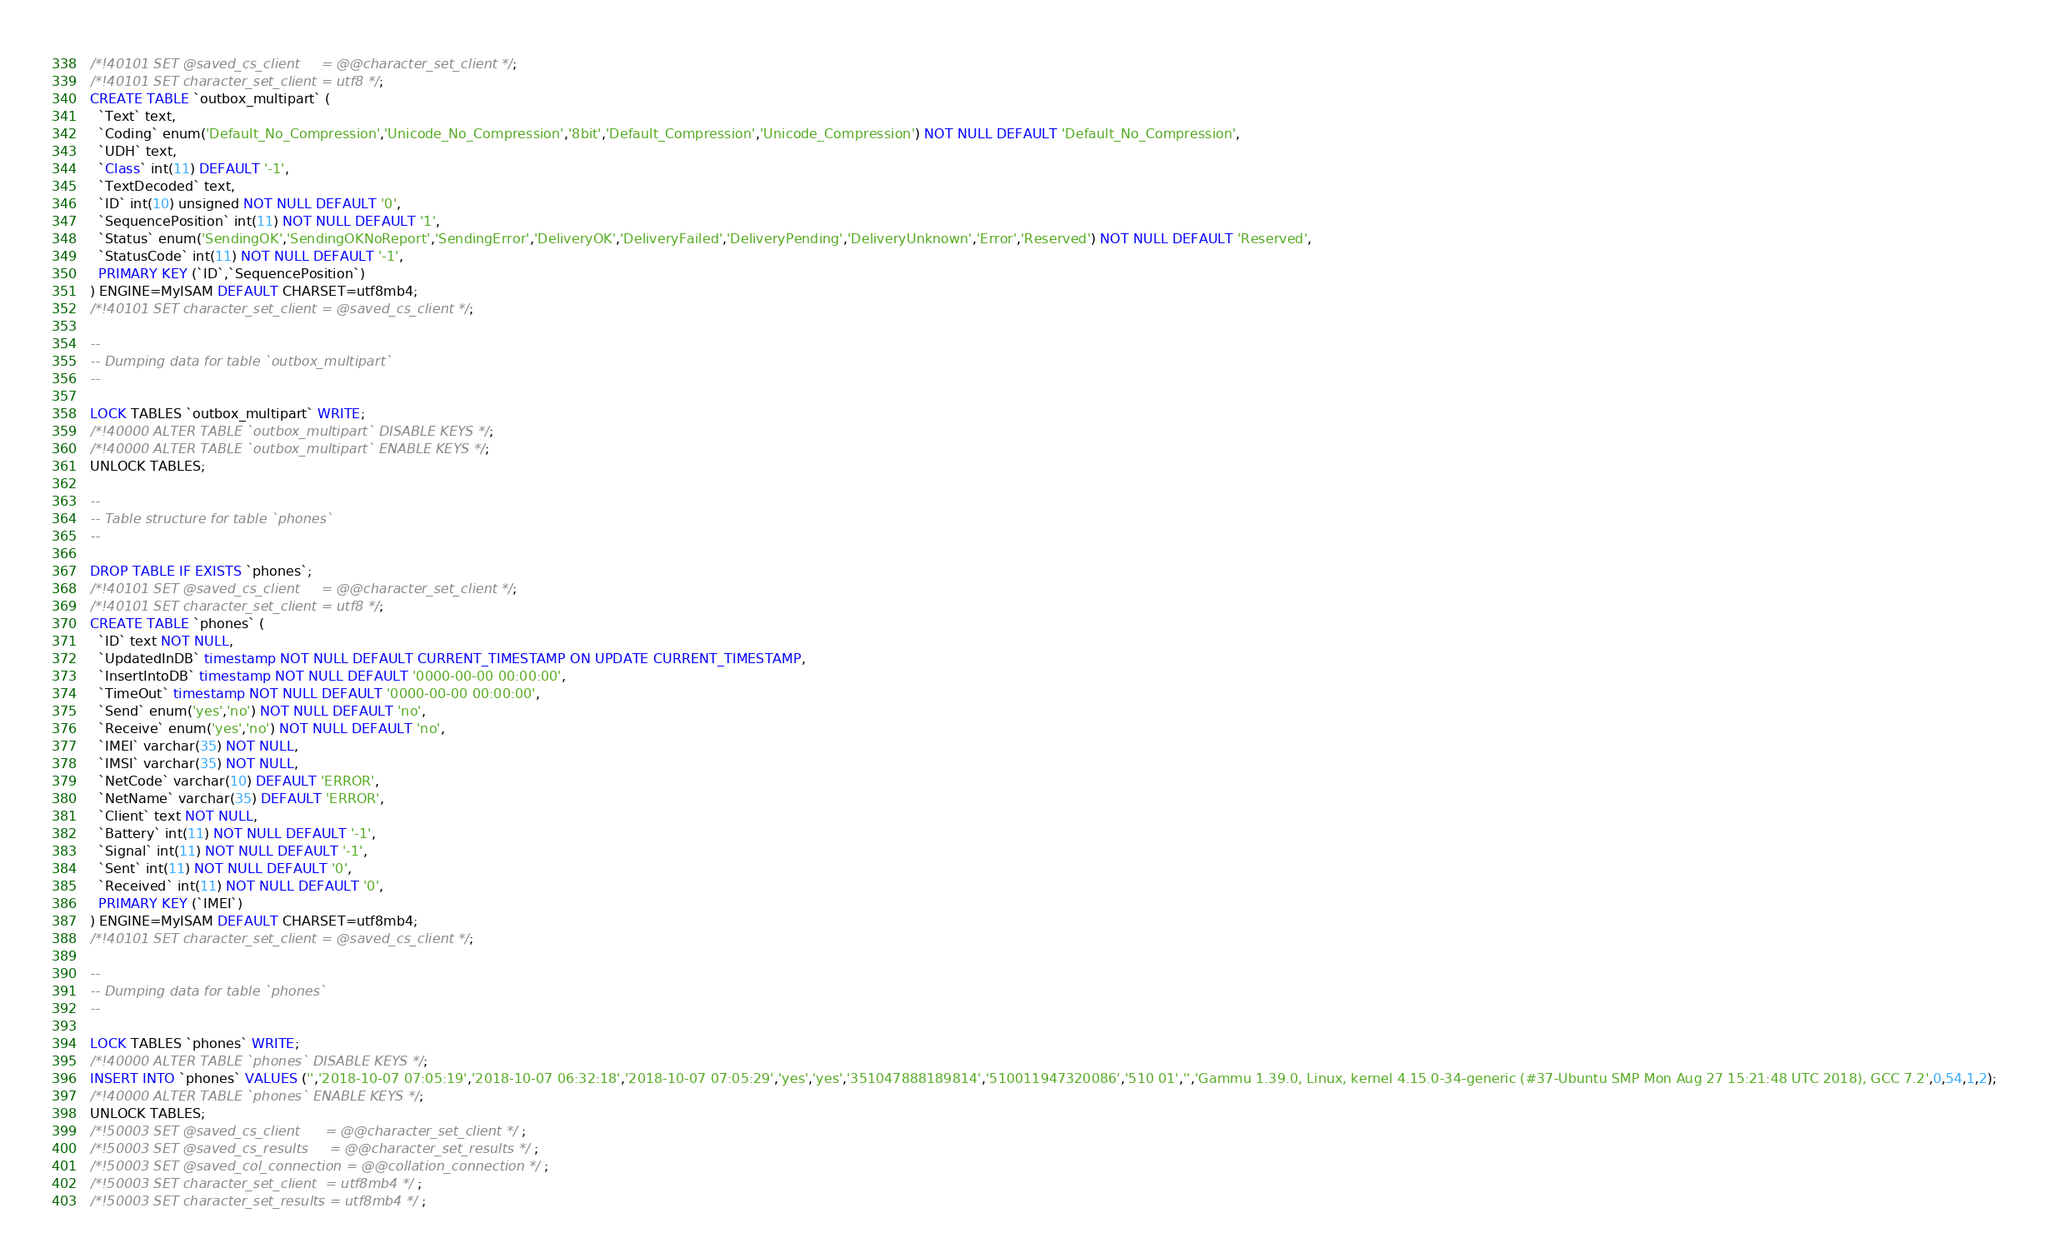Convert code to text. <code><loc_0><loc_0><loc_500><loc_500><_SQL_>/*!40101 SET @saved_cs_client     = @@character_set_client */;
/*!40101 SET character_set_client = utf8 */;
CREATE TABLE `outbox_multipart` (
  `Text` text,
  `Coding` enum('Default_No_Compression','Unicode_No_Compression','8bit','Default_Compression','Unicode_Compression') NOT NULL DEFAULT 'Default_No_Compression',
  `UDH` text,
  `Class` int(11) DEFAULT '-1',
  `TextDecoded` text,
  `ID` int(10) unsigned NOT NULL DEFAULT '0',
  `SequencePosition` int(11) NOT NULL DEFAULT '1',
  `Status` enum('SendingOK','SendingOKNoReport','SendingError','DeliveryOK','DeliveryFailed','DeliveryPending','DeliveryUnknown','Error','Reserved') NOT NULL DEFAULT 'Reserved',
  `StatusCode` int(11) NOT NULL DEFAULT '-1',
  PRIMARY KEY (`ID`,`SequencePosition`)
) ENGINE=MyISAM DEFAULT CHARSET=utf8mb4;
/*!40101 SET character_set_client = @saved_cs_client */;

--
-- Dumping data for table `outbox_multipart`
--

LOCK TABLES `outbox_multipart` WRITE;
/*!40000 ALTER TABLE `outbox_multipart` DISABLE KEYS */;
/*!40000 ALTER TABLE `outbox_multipart` ENABLE KEYS */;
UNLOCK TABLES;

--
-- Table structure for table `phones`
--

DROP TABLE IF EXISTS `phones`;
/*!40101 SET @saved_cs_client     = @@character_set_client */;
/*!40101 SET character_set_client = utf8 */;
CREATE TABLE `phones` (
  `ID` text NOT NULL,
  `UpdatedInDB` timestamp NOT NULL DEFAULT CURRENT_TIMESTAMP ON UPDATE CURRENT_TIMESTAMP,
  `InsertIntoDB` timestamp NOT NULL DEFAULT '0000-00-00 00:00:00',
  `TimeOut` timestamp NOT NULL DEFAULT '0000-00-00 00:00:00',
  `Send` enum('yes','no') NOT NULL DEFAULT 'no',
  `Receive` enum('yes','no') NOT NULL DEFAULT 'no',
  `IMEI` varchar(35) NOT NULL,
  `IMSI` varchar(35) NOT NULL,
  `NetCode` varchar(10) DEFAULT 'ERROR',
  `NetName` varchar(35) DEFAULT 'ERROR',
  `Client` text NOT NULL,
  `Battery` int(11) NOT NULL DEFAULT '-1',
  `Signal` int(11) NOT NULL DEFAULT '-1',
  `Sent` int(11) NOT NULL DEFAULT '0',
  `Received` int(11) NOT NULL DEFAULT '0',
  PRIMARY KEY (`IMEI`)
) ENGINE=MyISAM DEFAULT CHARSET=utf8mb4;
/*!40101 SET character_set_client = @saved_cs_client */;

--
-- Dumping data for table `phones`
--

LOCK TABLES `phones` WRITE;
/*!40000 ALTER TABLE `phones` DISABLE KEYS */;
INSERT INTO `phones` VALUES ('','2018-10-07 07:05:19','2018-10-07 06:32:18','2018-10-07 07:05:29','yes','yes','351047888189814','510011947320086','510 01','','Gammu 1.39.0, Linux, kernel 4.15.0-34-generic (#37-Ubuntu SMP Mon Aug 27 15:21:48 UTC 2018), GCC 7.2',0,54,1,2);
/*!40000 ALTER TABLE `phones` ENABLE KEYS */;
UNLOCK TABLES;
/*!50003 SET @saved_cs_client      = @@character_set_client */ ;
/*!50003 SET @saved_cs_results     = @@character_set_results */ ;
/*!50003 SET @saved_col_connection = @@collation_connection */ ;
/*!50003 SET character_set_client  = utf8mb4 */ ;
/*!50003 SET character_set_results = utf8mb4 */ ;</code> 